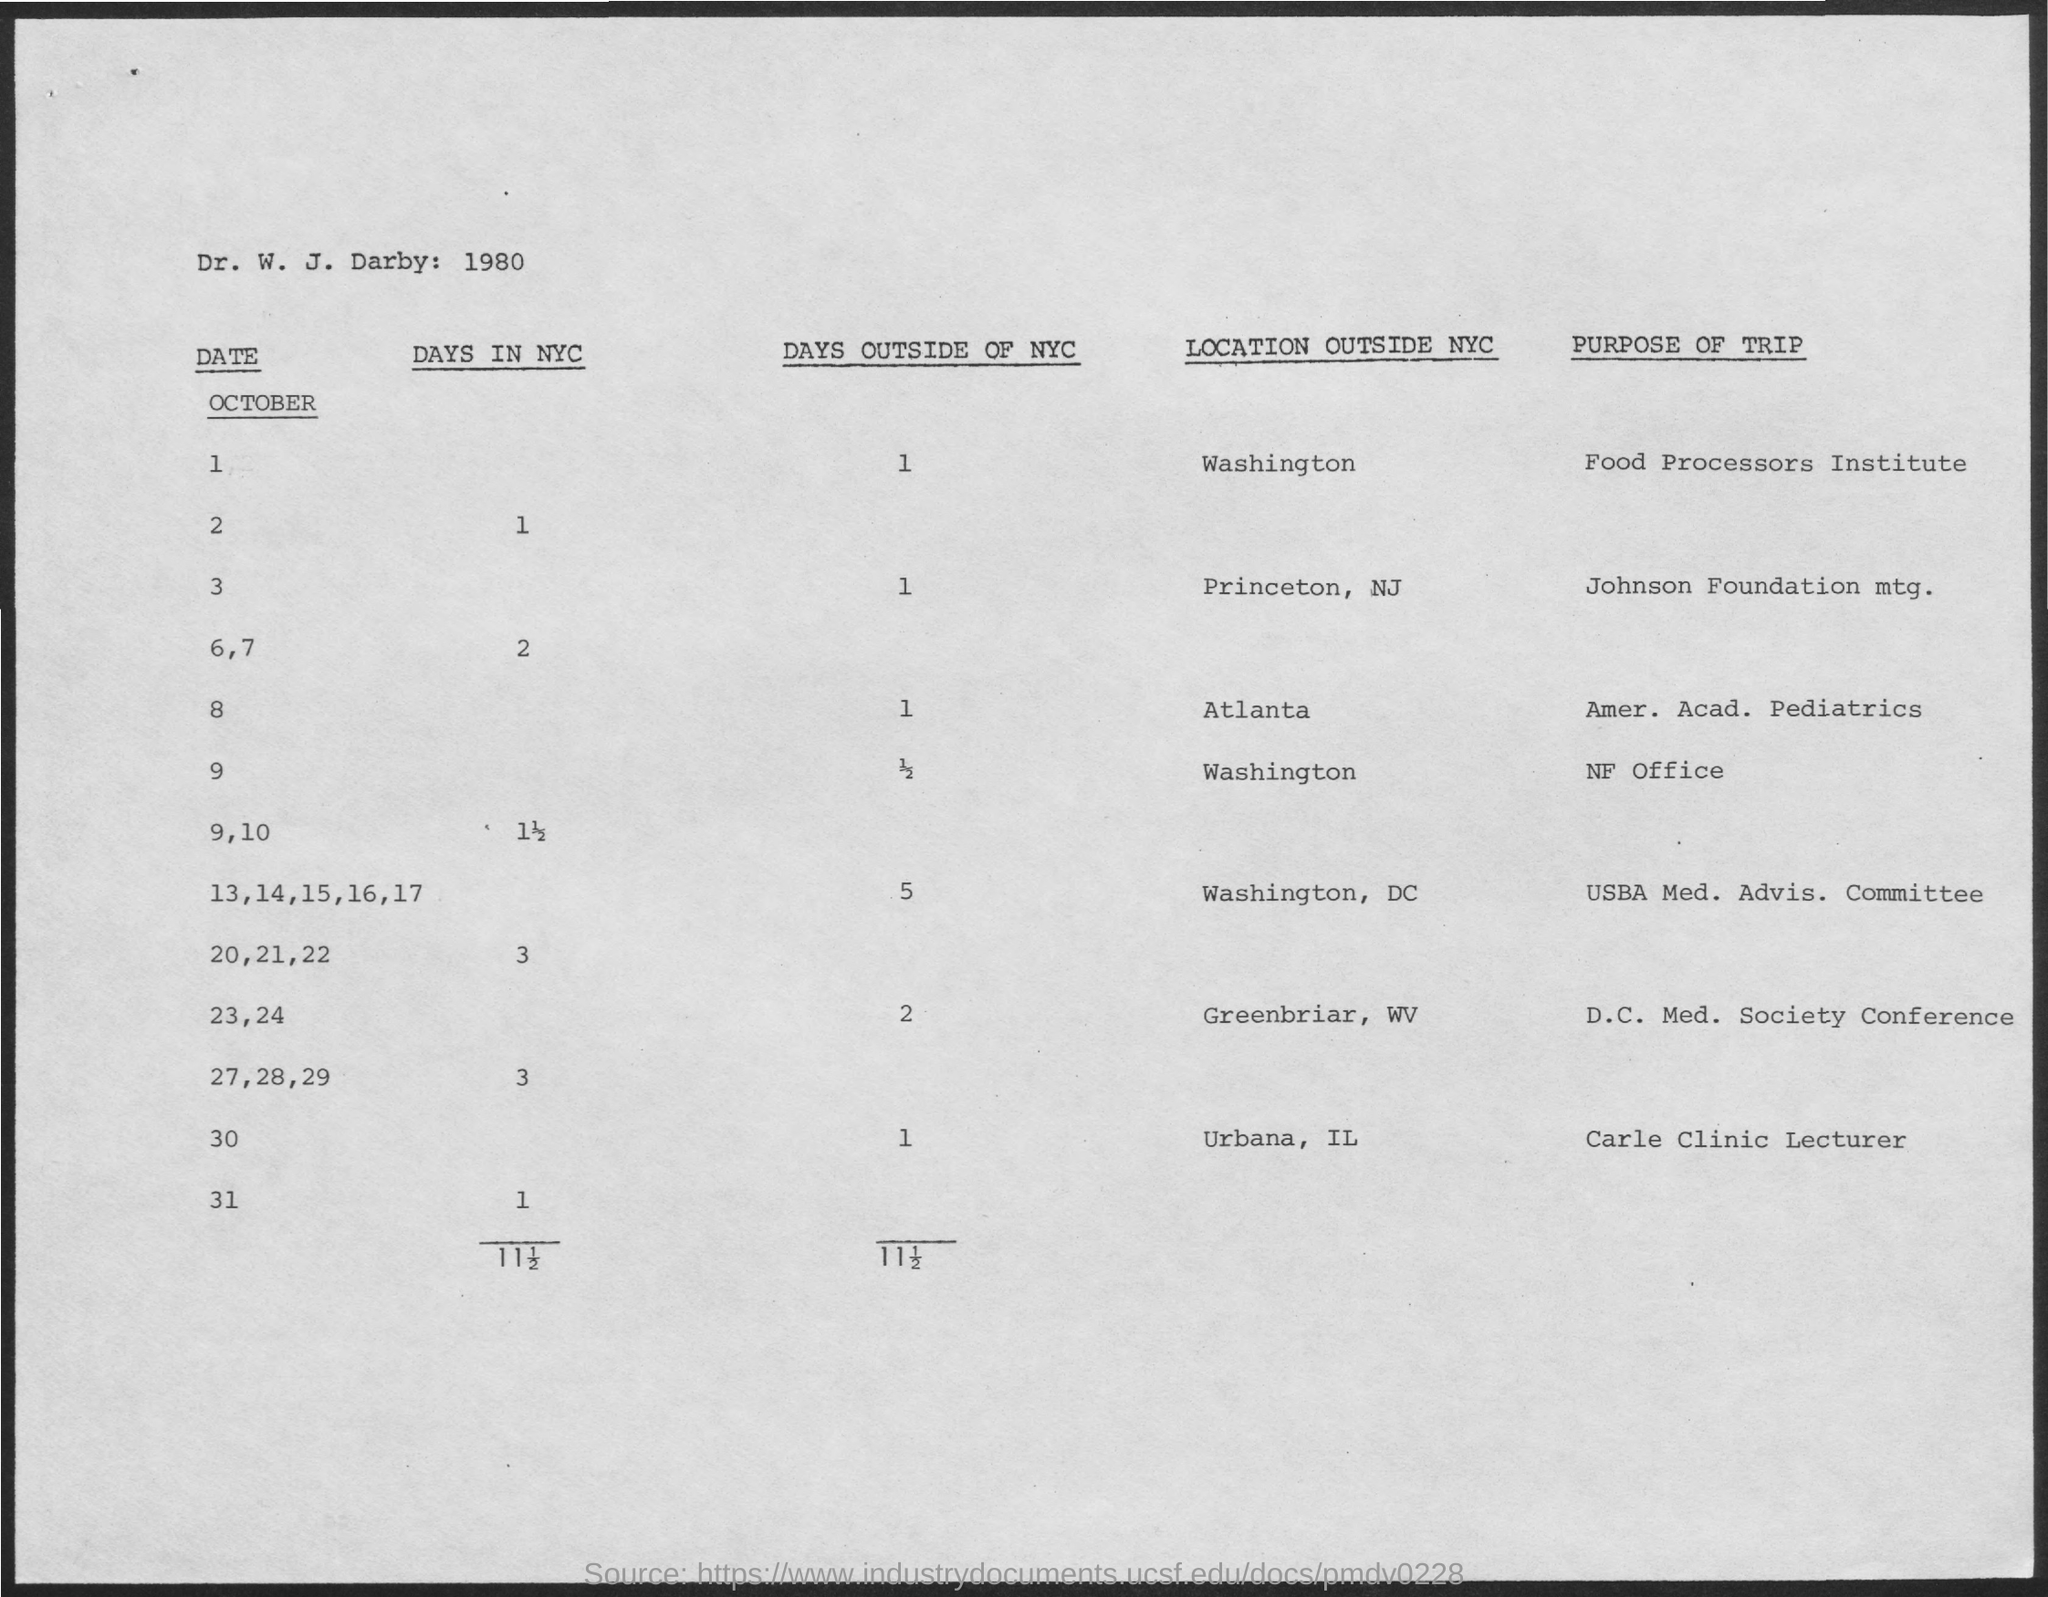What is the number of days outside of NYC on October 1?
Give a very brief answer. 1. What is the purpose of trip on October 1?
Offer a terse response. Food Processors Institute. What is the purpose of trip on October 3?
Offer a terse response. Johnson Foundation mtg. What is the location outside NYC on October 1?
Your answer should be compact. Washington. What is the location outside NYC on October 8?
Your response must be concise. Atlanta. 